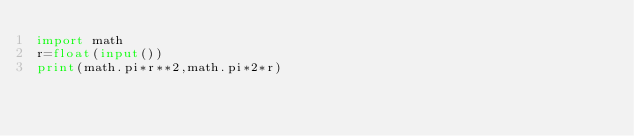Convert code to text. <code><loc_0><loc_0><loc_500><loc_500><_Python_>import math
r=float(input())
print(math.pi*r**2,math.pi*2*r)
</code> 